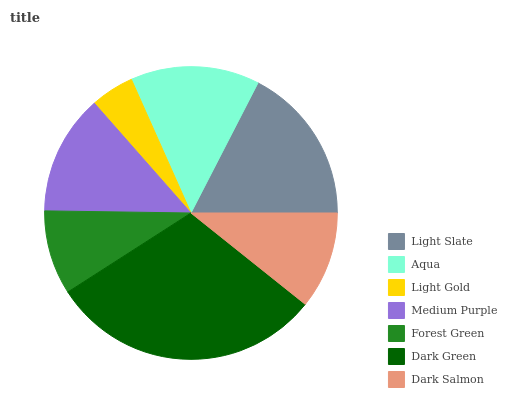Is Light Gold the minimum?
Answer yes or no. Yes. Is Dark Green the maximum?
Answer yes or no. Yes. Is Aqua the minimum?
Answer yes or no. No. Is Aqua the maximum?
Answer yes or no. No. Is Light Slate greater than Aqua?
Answer yes or no. Yes. Is Aqua less than Light Slate?
Answer yes or no. Yes. Is Aqua greater than Light Slate?
Answer yes or no. No. Is Light Slate less than Aqua?
Answer yes or no. No. Is Medium Purple the high median?
Answer yes or no. Yes. Is Medium Purple the low median?
Answer yes or no. Yes. Is Dark Salmon the high median?
Answer yes or no. No. Is Light Slate the low median?
Answer yes or no. No. 